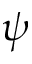Convert formula to latex. <formula><loc_0><loc_0><loc_500><loc_500>\psi</formula> 